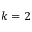Convert formula to latex. <formula><loc_0><loc_0><loc_500><loc_500>k = 2</formula> 